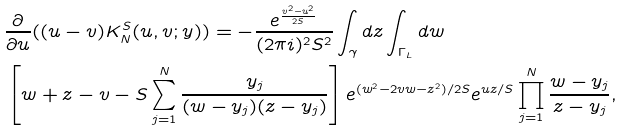<formula> <loc_0><loc_0><loc_500><loc_500>& \frac { \partial } { \partial u } ( ( u - v ) K _ { N } ^ { S } ( u , v ; y ) ) = - \frac { e ^ { \frac { v ^ { 2 } - u ^ { 2 } } { 2 S } } } { ( 2 \pi i ) ^ { 2 } S ^ { 2 } } \int _ { \gamma } d z \int _ { \Gamma _ { L } } d w \\ & \left [ w + z - v - S \sum _ { j = 1 } ^ { N } \frac { y _ { j } } { ( w - y _ { j } ) ( z - y _ { j } ) } \right ] e ^ { ( w ^ { 2 } - 2 v w - z ^ { 2 } ) / 2 S } e ^ { u z / S } \prod _ { j = 1 } ^ { N } \frac { w - y _ { j } } { z - y _ { j } } ,</formula> 